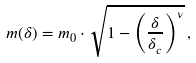<formula> <loc_0><loc_0><loc_500><loc_500>m ( \delta ) = m _ { 0 } \cdot \sqrt { 1 - \left ( \frac { \delta } { \delta _ { c } } \right ) ^ { \nu } } \, ,</formula> 